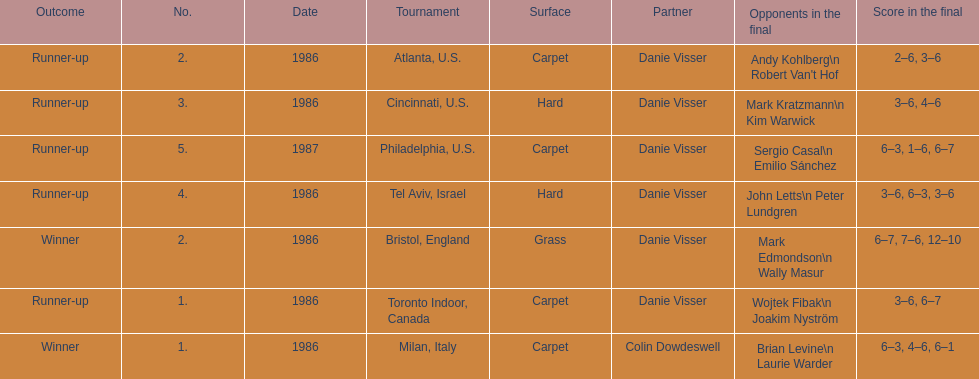Who is the last partner listed? Danie Visser. 